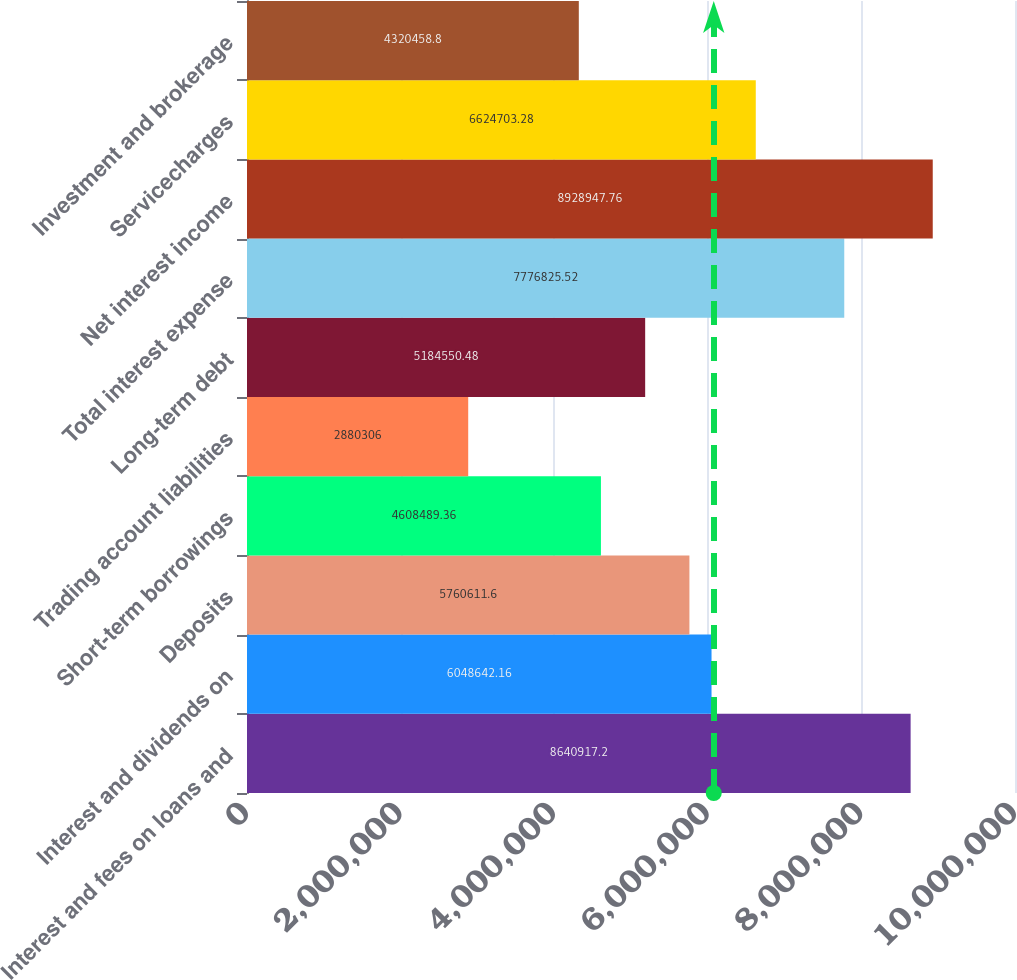Convert chart to OTSL. <chart><loc_0><loc_0><loc_500><loc_500><bar_chart><fcel>Interest and fees on loans and<fcel>Interest and dividends on<fcel>Deposits<fcel>Short-term borrowings<fcel>Trading account liabilities<fcel>Long-term debt<fcel>Total interest expense<fcel>Net interest income<fcel>Servicecharges<fcel>Investment and brokerage<nl><fcel>8.64092e+06<fcel>6.04864e+06<fcel>5.76061e+06<fcel>4.60849e+06<fcel>2.88031e+06<fcel>5.18455e+06<fcel>7.77683e+06<fcel>8.92895e+06<fcel>6.6247e+06<fcel>4.32046e+06<nl></chart> 